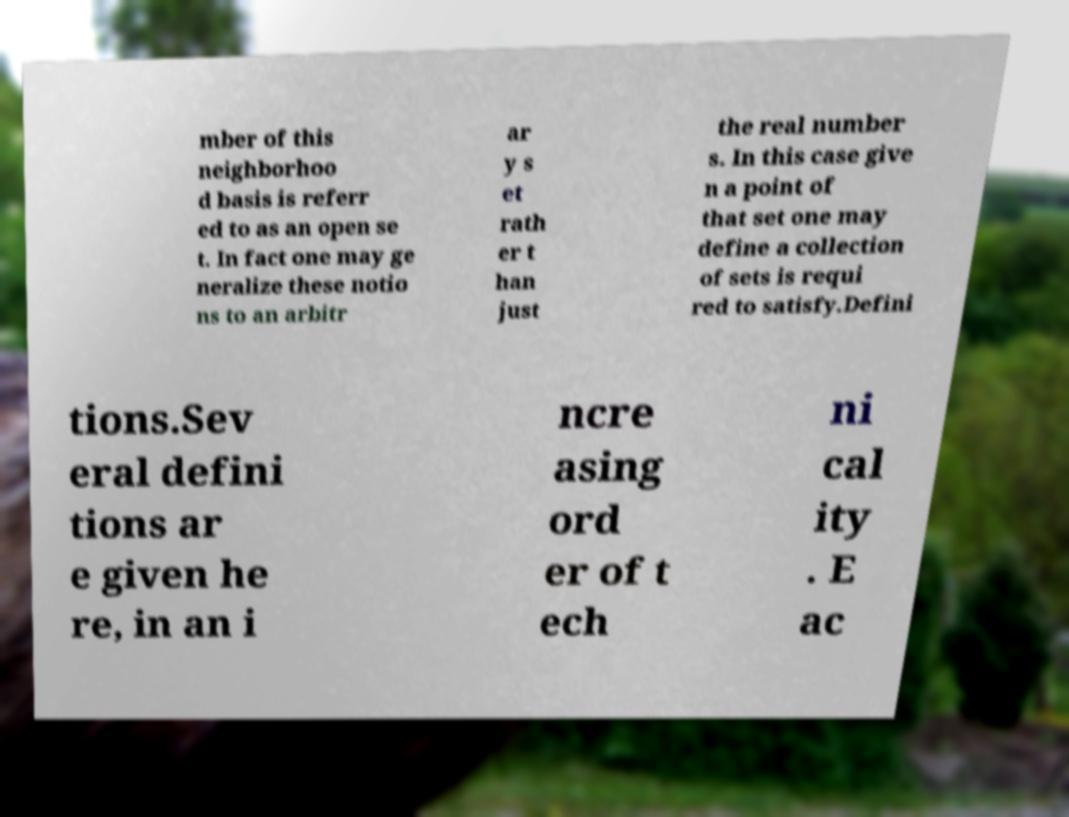Can you read and provide the text displayed in the image?This photo seems to have some interesting text. Can you extract and type it out for me? mber of this neighborhoo d basis is referr ed to as an open se t. In fact one may ge neralize these notio ns to an arbitr ar y s et rath er t han just the real number s. In this case give n a point of that set one may define a collection of sets is requi red to satisfy.Defini tions.Sev eral defini tions ar e given he re, in an i ncre asing ord er of t ech ni cal ity . E ac 